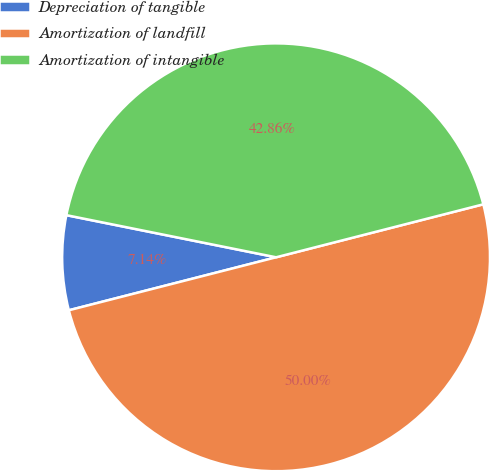Convert chart. <chart><loc_0><loc_0><loc_500><loc_500><pie_chart><fcel>Depreciation of tangible<fcel>Amortization of landfill<fcel>Amortization of intangible<nl><fcel>7.14%<fcel>50.0%<fcel>42.86%<nl></chart> 